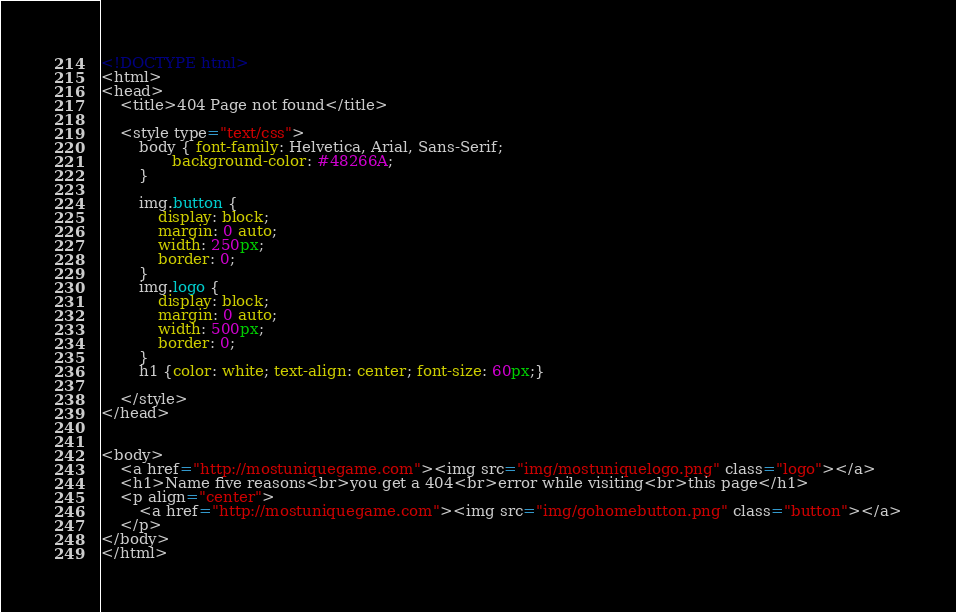Convert code to text. <code><loc_0><loc_0><loc_500><loc_500><_HTML_><!DOCTYPE html>
<html>
<head>
	<title>404 Page not found</title>

	<style type="text/css">
		body { font-family: Helvetica, Arial, Sans-Serif;
			   background-color: #48266A;
		}

		img.button {
    		display: block;
    		margin: 0 auto;
    		width: 250px;
    		border: 0;
		}
		img.logo {
    		display: block;
    		margin: 0 auto;
    		width: 500px;
    		border: 0;
		}
		h1 {color: white; text-align: center; font-size: 60px;}
		
	</style>
</head>


<body>
	<a href="http://mostuniquegame.com"><img src="img/mostuniquelogo.png" class="logo"></a>
	<h1>Name five reasons<br>you get a 404<br>error while visiting<br>this page</h1>
	<p align="center">
		<a href="http://mostuniquegame.com"><img src="img/gohomebutton.png" class="button"></a>
	</p>
</body>
</html></code> 